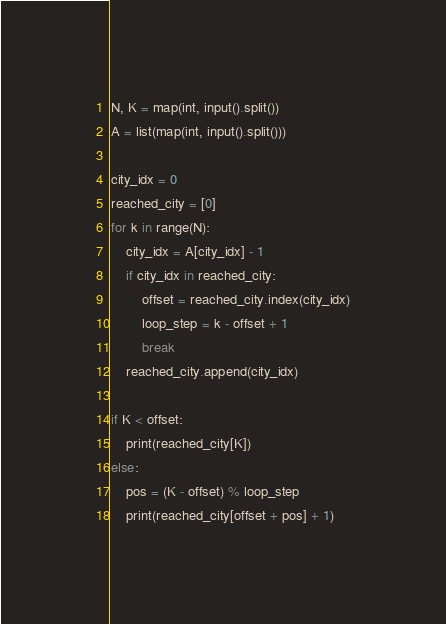<code> <loc_0><loc_0><loc_500><loc_500><_Python_>N, K = map(int, input().split())
A = list(map(int, input().split()))

city_idx = 0
reached_city = [0]
for k in range(N):
    city_idx = A[city_idx] - 1
    if city_idx in reached_city:
        offset = reached_city.index(city_idx)
        loop_step = k - offset + 1
        break
    reached_city.append(city_idx)

if K < offset:
    print(reached_city[K])
else:
    pos = (K - offset) % loop_step
    print(reached_city[offset + pos] + 1)
</code> 